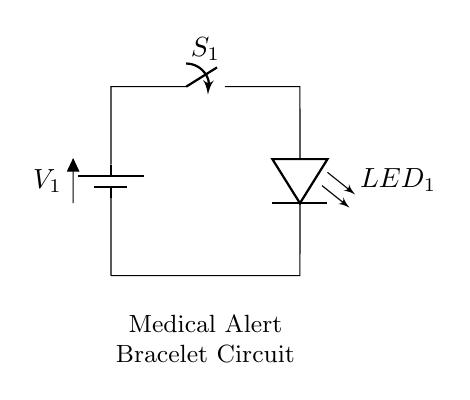What components are in the circuit? The circuit contains a battery, a switch, and an LED. These components are shown in the diagram, identifiable by their symbols.
Answer: battery, switch, LED What is the function of the switch in this circuit? The switch serves to open or close the circuit, allowing or interrupting the flow of electricity to the LED. When closed, it completes the circuit.
Answer: control current flow How many components are in series in this circuit? There are three components connected in series: the battery, the switch, and the LED. They are connected one after the other without any branches.
Answer: three What happens when the switch is open? When the switch is open, the circuit is incomplete, and current cannot flow to the LED, which means the LED will not light up.
Answer: LED off What type of circuit is depicted? The circuit is a series circuit, where all components are connected end-to-end, and the same current flows through each component.
Answer: series circuit What will the LED indicate when the switch is closed? When the switch is closed, the circuit is complete, enabling current to flow through the LED, causing it to light up and indicate that the system is active.
Answer: LED on 